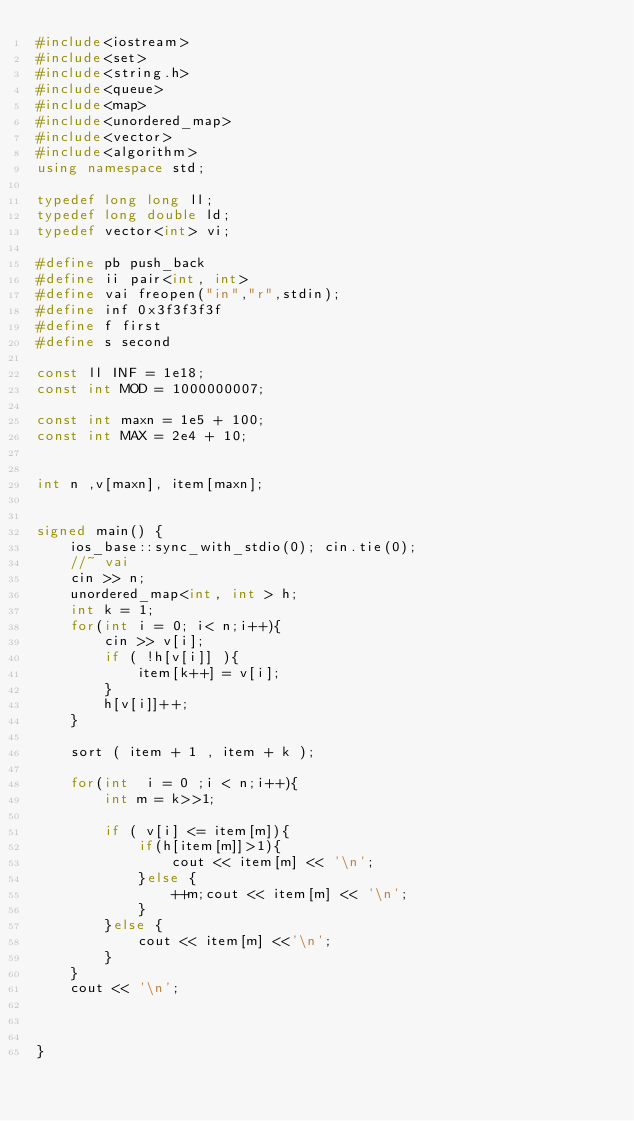<code> <loc_0><loc_0><loc_500><loc_500><_C++_>#include<iostream>
#include<set>
#include<string.h>
#include<queue>
#include<map>
#include<unordered_map>
#include<vector>
#include<algorithm>
using namespace std;
 
typedef long long ll;
typedef long double ld;
typedef vector<int> vi;
 
#define pb push_back
#define ii pair<int, int> 
#define vai freopen("in","r",stdin);
#define inf 0x3f3f3f3f
#define f first
#define s second

const ll INF = 1e18;
const int MOD = 1000000007;

const int maxn = 1e5 + 100;
const int MAX = 2e4 + 10;
 

int n ,v[maxn], item[maxn];

 
signed main() {
	ios_base::sync_with_stdio(0); cin.tie(0);
	//~ vai
	cin >> n;
	unordered_map<int, int > h;
	int k = 1;
	for(int i = 0; i< n;i++){
		cin >> v[i];
		if ( !h[v[i]] ){
			item[k++] = v[i];
		}
		h[v[i]]++;
	}
	
	sort ( item + 1 , item + k );
 
	for(int  i = 0 ;i < n;i++){
		int m = k>>1;
		
		if ( v[i] <= item[m]){
			if(h[item[m]]>1){
				cout << item[m] << '\n';
			}else {
				++m;cout << item[m] << '\n';
			}
		}else {
			cout << item[m] <<'\n';
		}
	}
	cout << '\n';
	
	
	 
}
 
	
</code> 